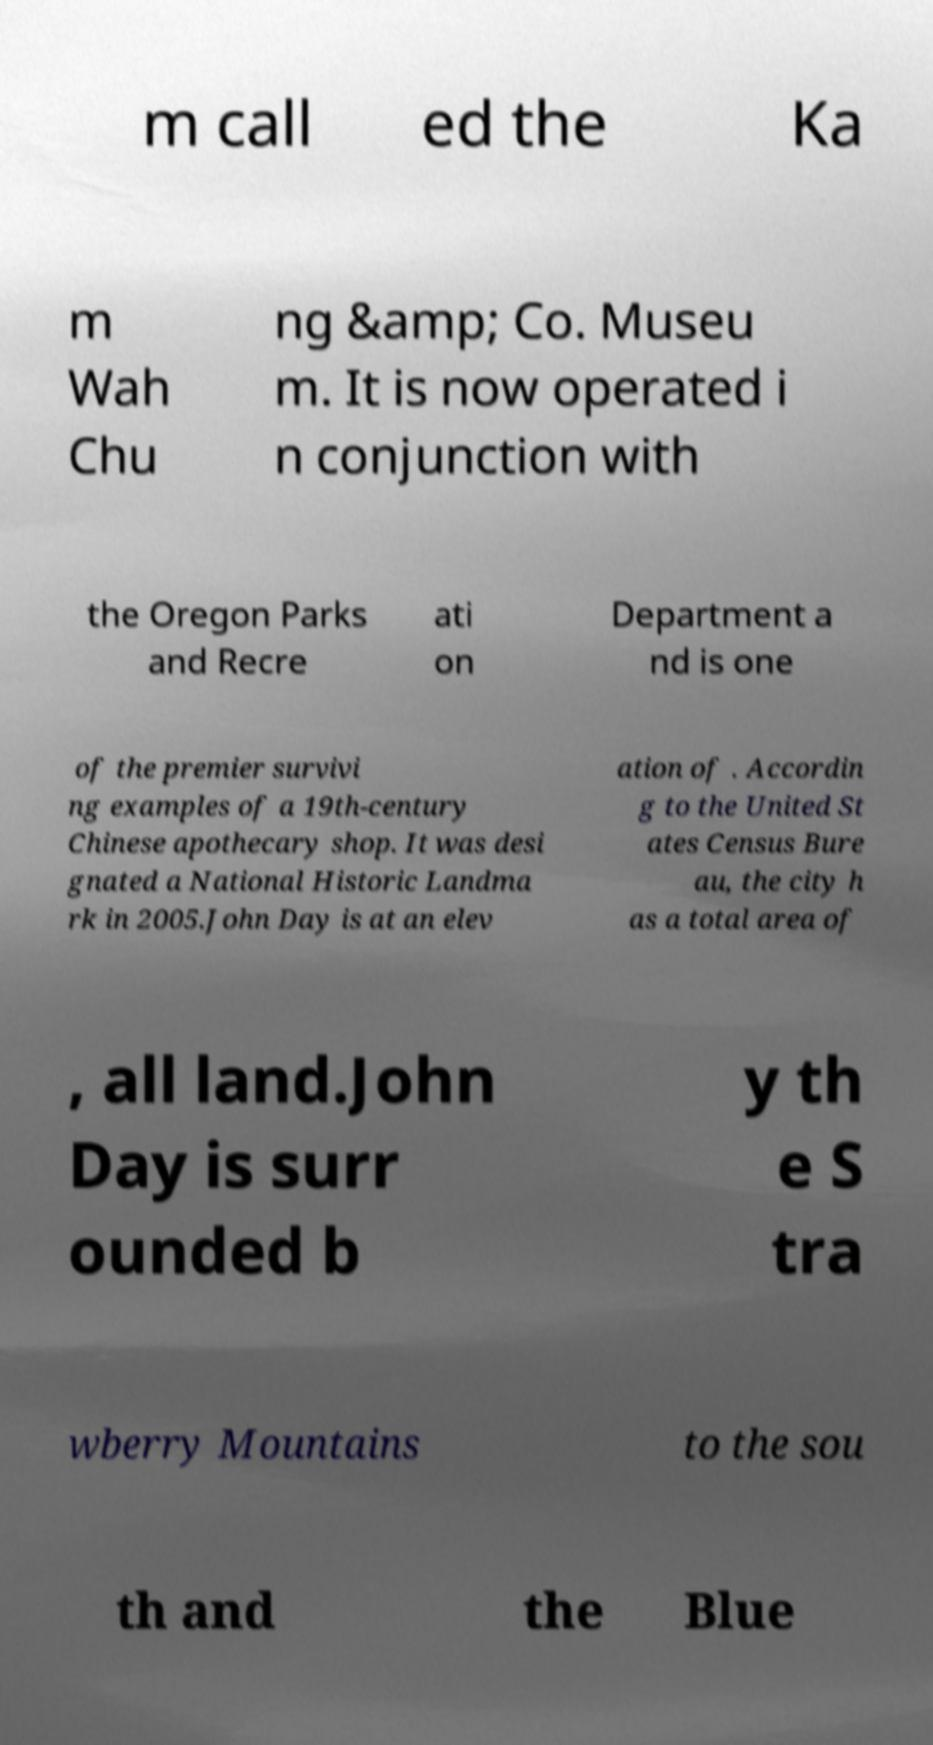Can you read and provide the text displayed in the image?This photo seems to have some interesting text. Can you extract and type it out for me? m call ed the Ka m Wah Chu ng &amp; Co. Museu m. It is now operated i n conjunction with the Oregon Parks and Recre ati on Department a nd is one of the premier survivi ng examples of a 19th-century Chinese apothecary shop. It was desi gnated a National Historic Landma rk in 2005.John Day is at an elev ation of . Accordin g to the United St ates Census Bure au, the city h as a total area of , all land.John Day is surr ounded b y th e S tra wberry Mountains to the sou th and the Blue 